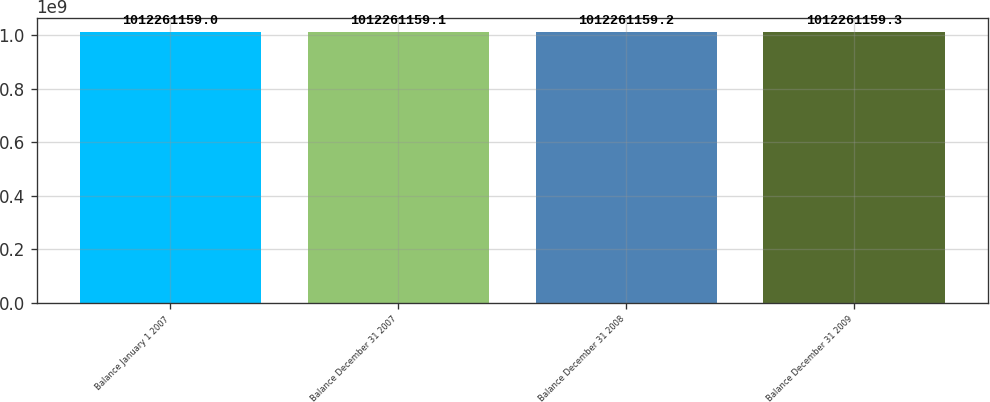Convert chart to OTSL. <chart><loc_0><loc_0><loc_500><loc_500><bar_chart><fcel>Balance January 1 2007<fcel>Balance December 31 2007<fcel>Balance December 31 2008<fcel>Balance December 31 2009<nl><fcel>1.01226e+09<fcel>1.01226e+09<fcel>1.01226e+09<fcel>1.01226e+09<nl></chart> 